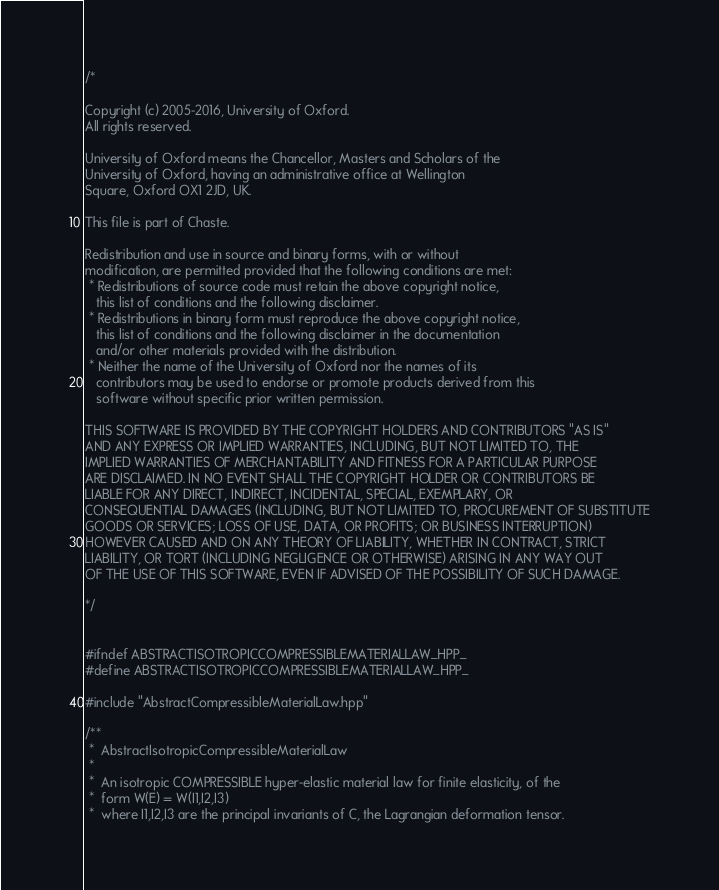Convert code to text. <code><loc_0><loc_0><loc_500><loc_500><_C++_>/*

Copyright (c) 2005-2016, University of Oxford.
All rights reserved.

University of Oxford means the Chancellor, Masters and Scholars of the
University of Oxford, having an administrative office at Wellington
Square, Oxford OX1 2JD, UK.

This file is part of Chaste.

Redistribution and use in source and binary forms, with or without
modification, are permitted provided that the following conditions are met:
 * Redistributions of source code must retain the above copyright notice,
   this list of conditions and the following disclaimer.
 * Redistributions in binary form must reproduce the above copyright notice,
   this list of conditions and the following disclaimer in the documentation
   and/or other materials provided with the distribution.
 * Neither the name of the University of Oxford nor the names of its
   contributors may be used to endorse or promote products derived from this
   software without specific prior written permission.

THIS SOFTWARE IS PROVIDED BY THE COPYRIGHT HOLDERS AND CONTRIBUTORS "AS IS"
AND ANY EXPRESS OR IMPLIED WARRANTIES, INCLUDING, BUT NOT LIMITED TO, THE
IMPLIED WARRANTIES OF MERCHANTABILITY AND FITNESS FOR A PARTICULAR PURPOSE
ARE DISCLAIMED. IN NO EVENT SHALL THE COPYRIGHT HOLDER OR CONTRIBUTORS BE
LIABLE FOR ANY DIRECT, INDIRECT, INCIDENTAL, SPECIAL, EXEMPLARY, OR
CONSEQUENTIAL DAMAGES (INCLUDING, BUT NOT LIMITED TO, PROCUREMENT OF SUBSTITUTE
GOODS OR SERVICES; LOSS OF USE, DATA, OR PROFITS; OR BUSINESS INTERRUPTION)
HOWEVER CAUSED AND ON ANY THEORY OF LIABILITY, WHETHER IN CONTRACT, STRICT
LIABILITY, OR TORT (INCLUDING NEGLIGENCE OR OTHERWISE) ARISING IN ANY WAY OUT
OF THE USE OF THIS SOFTWARE, EVEN IF ADVISED OF THE POSSIBILITY OF SUCH DAMAGE.

*/


#ifndef ABSTRACTISOTROPICCOMPRESSIBLEMATERIALLAW_HPP_
#define ABSTRACTISOTROPICCOMPRESSIBLEMATERIALLAW_HPP_

#include "AbstractCompressibleMaterialLaw.hpp"

/**
 *  AbstractIsotropicCompressibleMaterialLaw
 *
 *  An isotropic COMPRESSIBLE hyper-elastic material law for finite elasticity, of the
 *  form W(E) = W(I1,I2,I3)
 *  where I1,I2,I3 are the principal invariants of C, the Lagrangian deformation tensor.</code> 